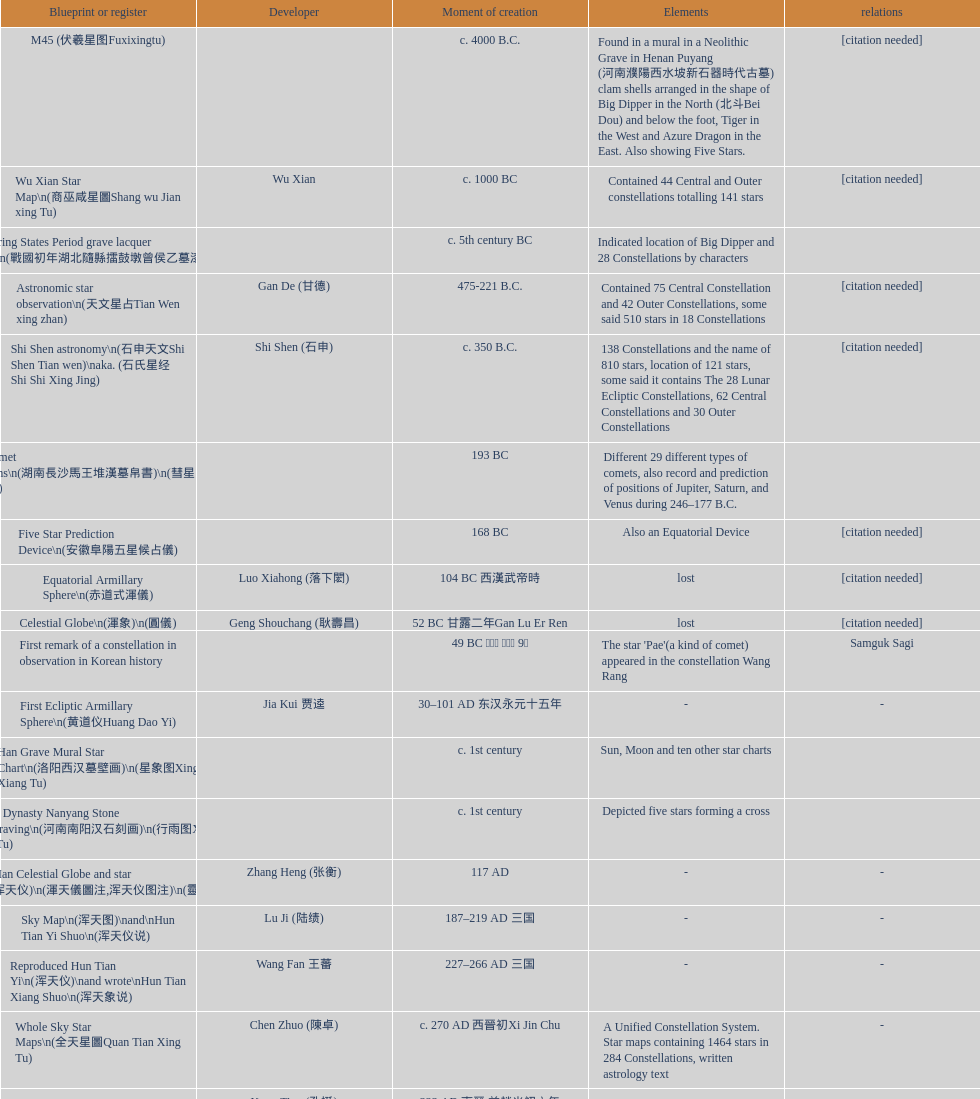Which atlas or register was established latest? Sky in Google Earth KML. 